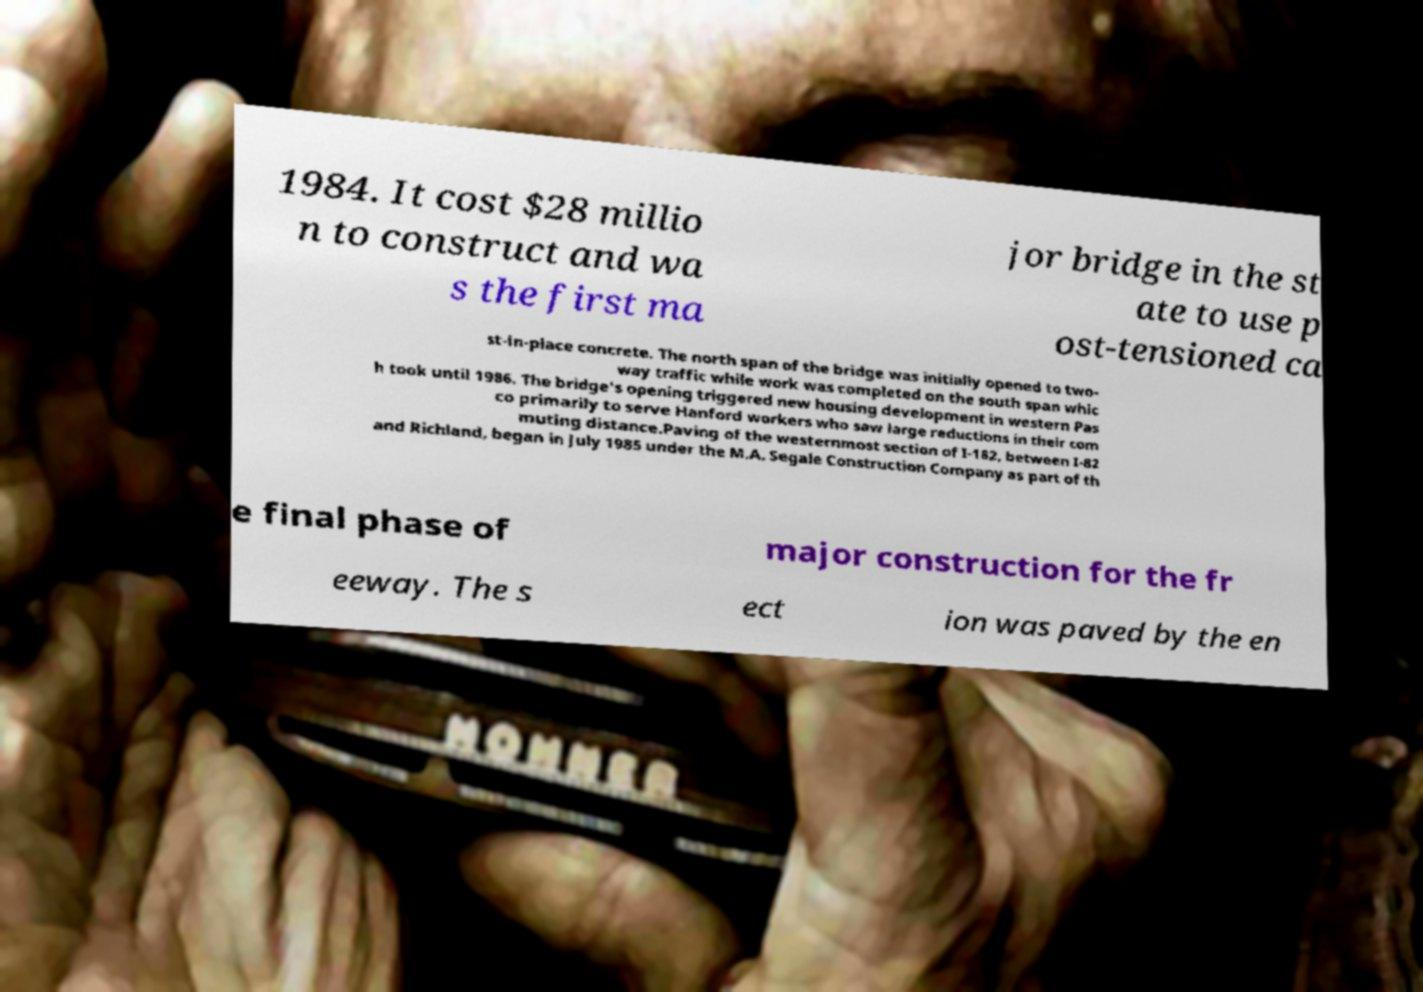For documentation purposes, I need the text within this image transcribed. Could you provide that? 1984. It cost $28 millio n to construct and wa s the first ma jor bridge in the st ate to use p ost-tensioned ca st-in-place concrete. The north span of the bridge was initially opened to two- way traffic while work was completed on the south span whic h took until 1986. The bridge's opening triggered new housing development in western Pas co primarily to serve Hanford workers who saw large reductions in their com muting distance.Paving of the westernmost section of I-182, between I-82 and Richland, began in July 1985 under the M.A. Segale Construction Company as part of th e final phase of major construction for the fr eeway. The s ect ion was paved by the en 